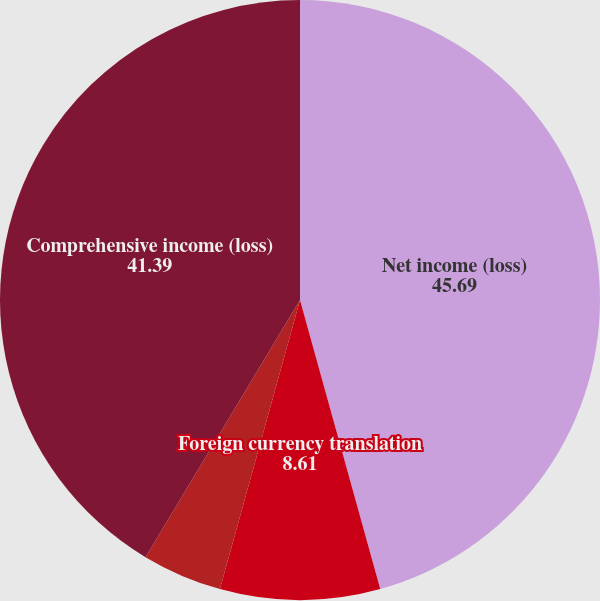Convert chart. <chart><loc_0><loc_0><loc_500><loc_500><pie_chart><fcel>Net income (loss)<fcel>Foreign currency translation<fcel>Other<fcel>Other comprehensive income<fcel>Comprehensive income (loss)<nl><fcel>45.69%<fcel>8.61%<fcel>0.0%<fcel>4.31%<fcel>41.39%<nl></chart> 